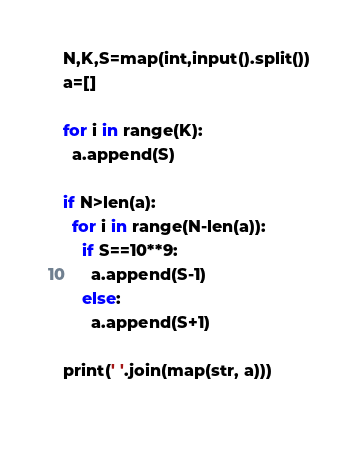<code> <loc_0><loc_0><loc_500><loc_500><_Python_>N,K,S=map(int,input().split())
a=[]

for i in range(K):
  a.append(S)

if N>len(a):
  for i in range(N-len(a)):
    if S==10**9:
      a.append(S-1)
    else:
      a.append(S+1)
      
print(' '.join(map(str, a)))
  
</code> 